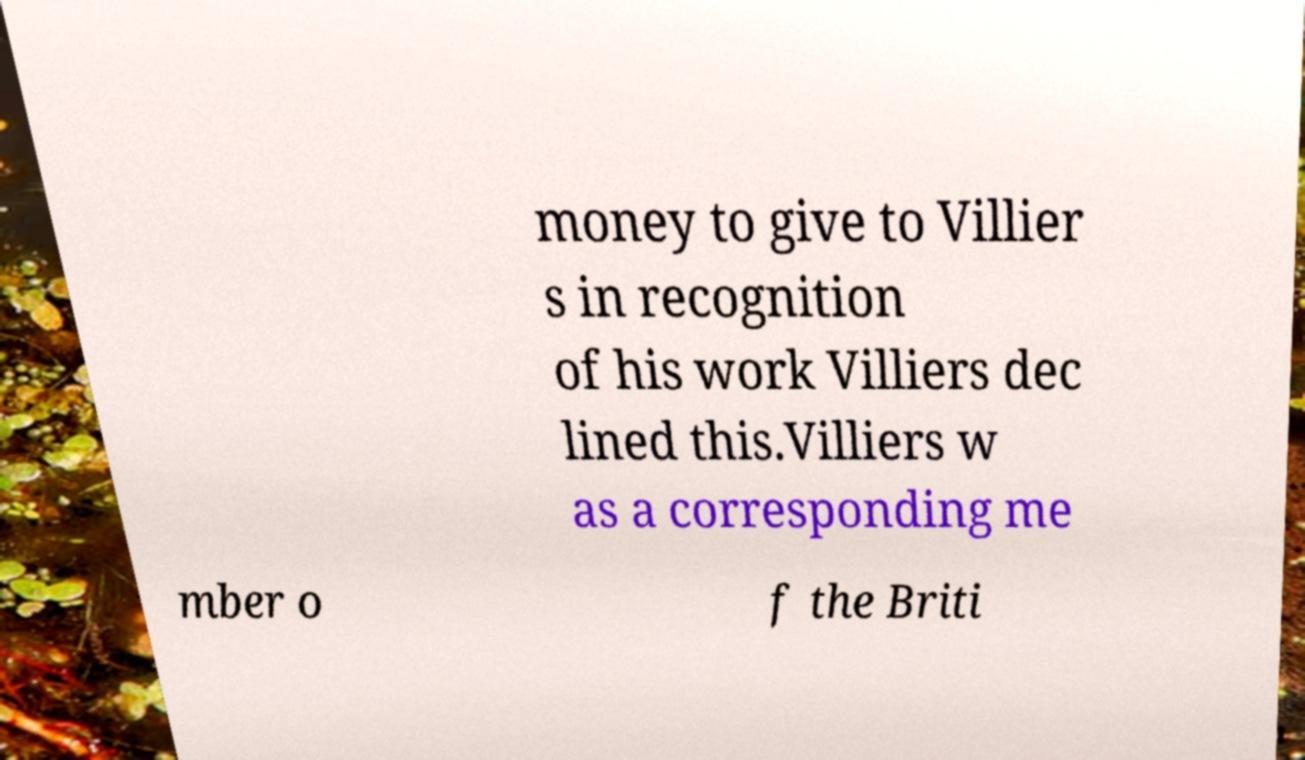Can you read and provide the text displayed in the image?This photo seems to have some interesting text. Can you extract and type it out for me? money to give to Villier s in recognition of his work Villiers dec lined this.Villiers w as a corresponding me mber o f the Briti 